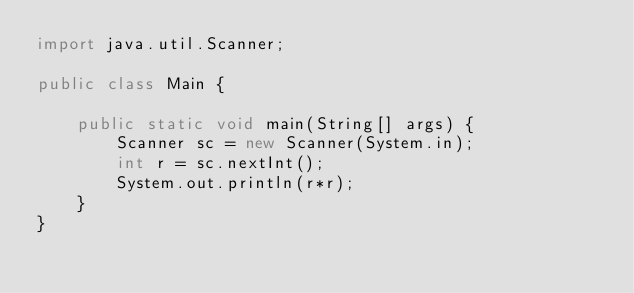Convert code to text. <code><loc_0><loc_0><loc_500><loc_500><_Java_>import java.util.Scanner;

public class Main {

	public static void main(String[] args) {
		Scanner sc = new Scanner(System.in);
		int r = sc.nextInt();
		System.out.println(r*r);
	}
}
</code> 